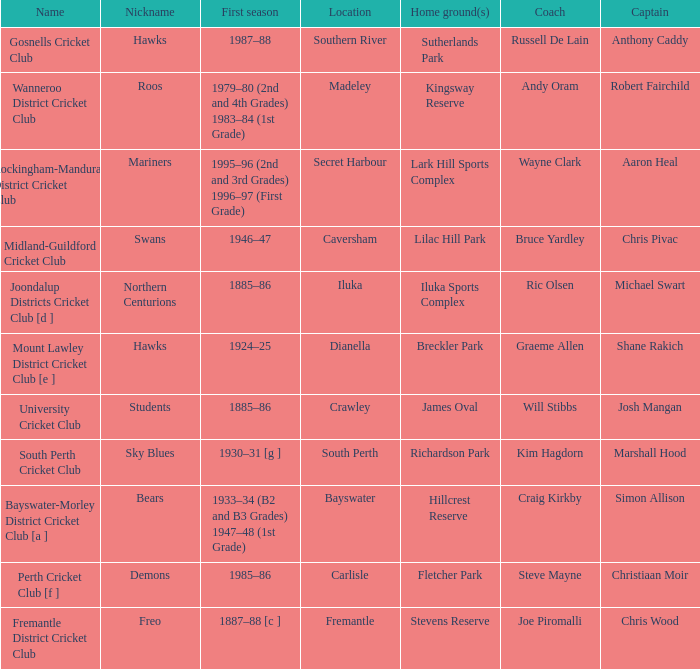Write the full table. {'header': ['Name', 'Nickname', 'First season', 'Location', 'Home ground(s)', 'Coach', 'Captain'], 'rows': [['Gosnells Cricket Club', 'Hawks', '1987–88', 'Southern River', 'Sutherlands Park', 'Russell De Lain', 'Anthony Caddy'], ['Wanneroo District Cricket Club', 'Roos', '1979–80 (2nd and 4th Grades) 1983–84 (1st Grade)', 'Madeley', 'Kingsway Reserve', 'Andy Oram', 'Robert Fairchild'], ['Rockingham-Mandurah District Cricket Club', 'Mariners', '1995–96 (2nd and 3rd Grades) 1996–97 (First Grade)', 'Secret Harbour', 'Lark Hill Sports Complex', 'Wayne Clark', 'Aaron Heal'], ['Midland-Guildford Cricket Club', 'Swans', '1946–47', 'Caversham', 'Lilac Hill Park', 'Bruce Yardley', 'Chris Pivac'], ['Joondalup Districts Cricket Club [d ]', 'Northern Centurions', '1885–86', 'Iluka', 'Iluka Sports Complex', 'Ric Olsen', 'Michael Swart'], ['Mount Lawley District Cricket Club [e ]', 'Hawks', '1924–25', 'Dianella', 'Breckler Park', 'Graeme Allen', 'Shane Rakich'], ['University Cricket Club', 'Students', '1885–86', 'Crawley', 'James Oval', 'Will Stibbs', 'Josh Mangan'], ['South Perth Cricket Club', 'Sky Blues', '1930–31 [g ]', 'South Perth', 'Richardson Park', 'Kim Hagdorn', 'Marshall Hood'], ['Bayswater-Morley District Cricket Club [a ]', 'Bears', '1933–34 (B2 and B3 Grades) 1947–48 (1st Grade)', 'Bayswater', 'Hillcrest Reserve', 'Craig Kirkby', 'Simon Allison'], ['Perth Cricket Club [f ]', 'Demons', '1985–86', 'Carlisle', 'Fletcher Park', 'Steve Mayne', 'Christiaan Moir'], ['Fremantle District Cricket Club', 'Freo', '1887–88 [c ]', 'Fremantle', 'Stevens Reserve', 'Joe Piromalli', 'Chris Wood']]} What is the dates where Hillcrest Reserve is the home grounds? 1933–34 (B2 and B3 Grades) 1947–48 (1st Grade). 